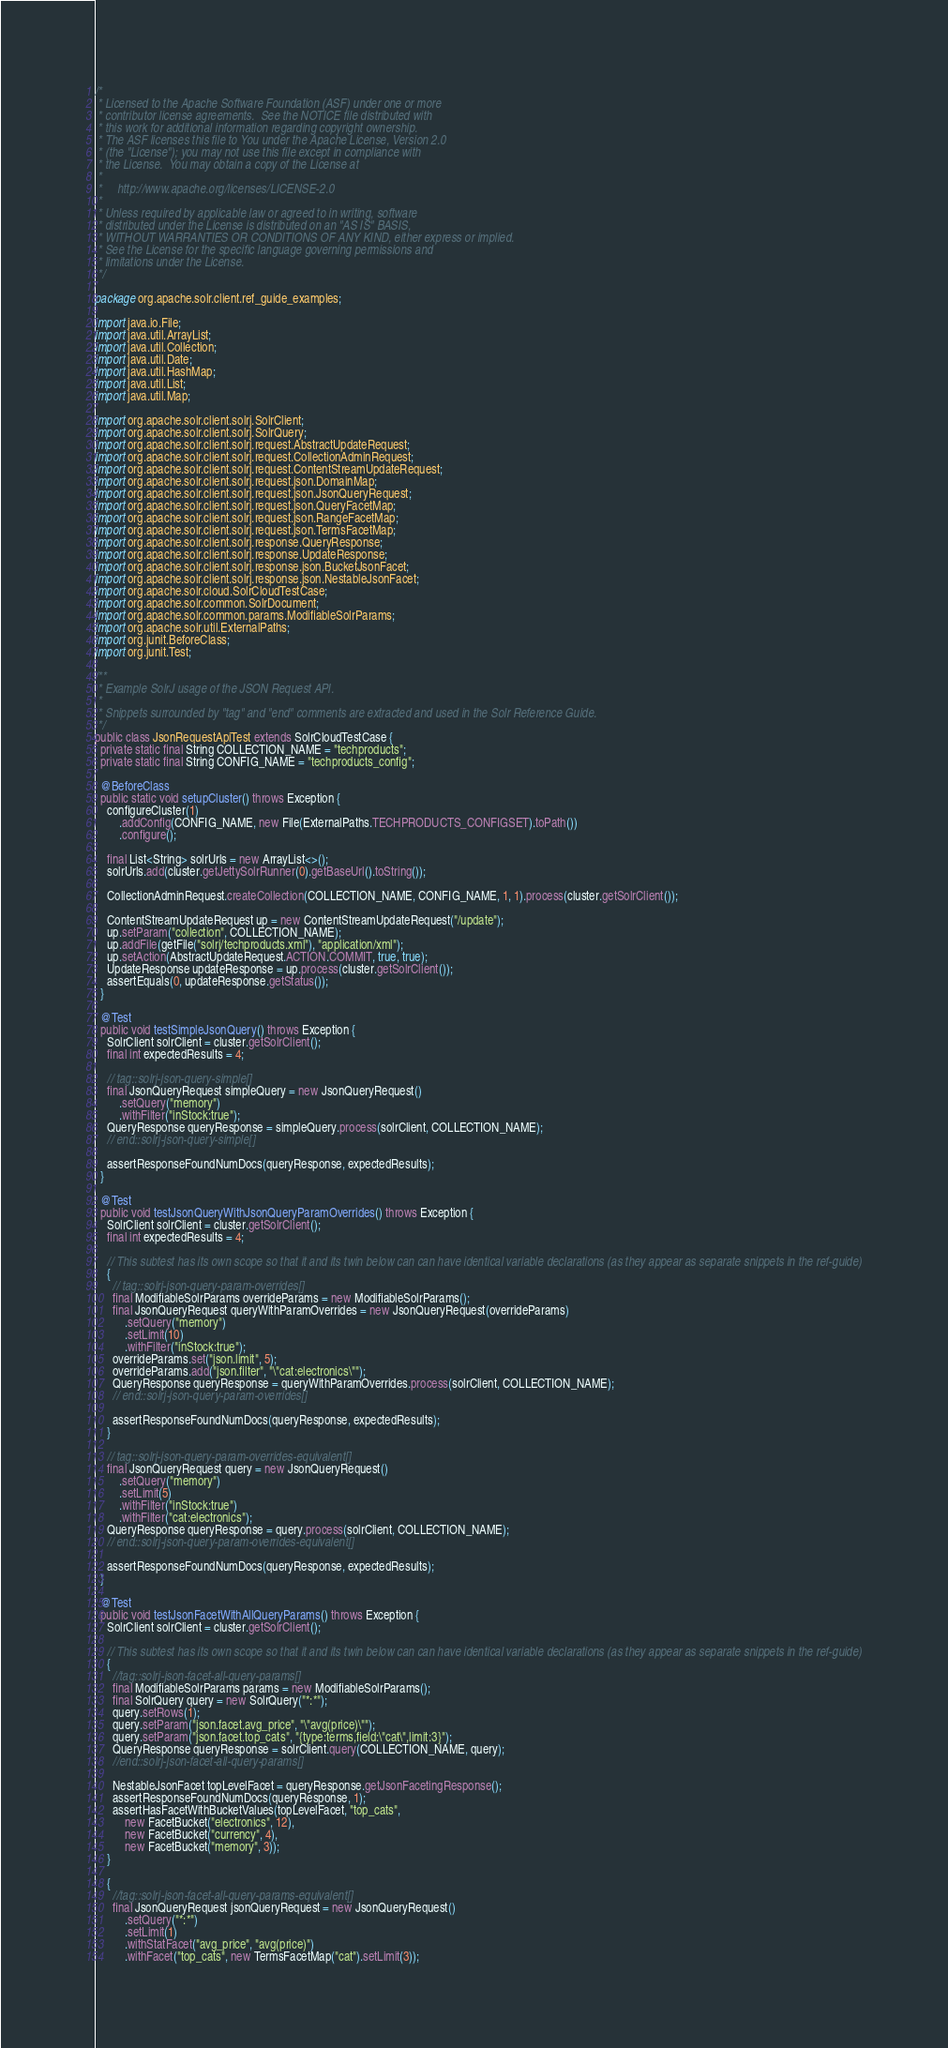<code> <loc_0><loc_0><loc_500><loc_500><_Java_>/*
 * Licensed to the Apache Software Foundation (ASF) under one or more
 * contributor license agreements.  See the NOTICE file distributed with
 * this work for additional information regarding copyright ownership.
 * The ASF licenses this file to You under the Apache License, Version 2.0
 * (the "License"); you may not use this file except in compliance with
 * the License.  You may obtain a copy of the License at
 *
 *     http://www.apache.org/licenses/LICENSE-2.0
 *
 * Unless required by applicable law or agreed to in writing, software
 * distributed under the License is distributed on an "AS IS" BASIS,
 * WITHOUT WARRANTIES OR CONDITIONS OF ANY KIND, either express or implied.
 * See the License for the specific language governing permissions and
 * limitations under the License.
 */

package org.apache.solr.client.ref_guide_examples;

import java.io.File;
import java.util.ArrayList;
import java.util.Collection;
import java.util.Date;
import java.util.HashMap;
import java.util.List;
import java.util.Map;

import org.apache.solr.client.solrj.SolrClient;
import org.apache.solr.client.solrj.SolrQuery;
import org.apache.solr.client.solrj.request.AbstractUpdateRequest;
import org.apache.solr.client.solrj.request.CollectionAdminRequest;
import org.apache.solr.client.solrj.request.ContentStreamUpdateRequest;
import org.apache.solr.client.solrj.request.json.DomainMap;
import org.apache.solr.client.solrj.request.json.JsonQueryRequest;
import org.apache.solr.client.solrj.request.json.QueryFacetMap;
import org.apache.solr.client.solrj.request.json.RangeFacetMap;
import org.apache.solr.client.solrj.request.json.TermsFacetMap;
import org.apache.solr.client.solrj.response.QueryResponse;
import org.apache.solr.client.solrj.response.UpdateResponse;
import org.apache.solr.client.solrj.response.json.BucketJsonFacet;
import org.apache.solr.client.solrj.response.json.NestableJsonFacet;
import org.apache.solr.cloud.SolrCloudTestCase;
import org.apache.solr.common.SolrDocument;
import org.apache.solr.common.params.ModifiableSolrParams;
import org.apache.solr.util.ExternalPaths;
import org.junit.BeforeClass;
import org.junit.Test;

/**
 * Example SolrJ usage of the JSON Request API.
 *
 * Snippets surrounded by "tag" and "end" comments are extracted and used in the Solr Reference Guide.
 */
public class JsonRequestApiTest extends SolrCloudTestCase {
  private static final String COLLECTION_NAME = "techproducts";
  private static final String CONFIG_NAME = "techproducts_config";

  @BeforeClass
  public static void setupCluster() throws Exception {
    configureCluster(1)
        .addConfig(CONFIG_NAME, new File(ExternalPaths.TECHPRODUCTS_CONFIGSET).toPath())
        .configure();

    final List<String> solrUrls = new ArrayList<>();
    solrUrls.add(cluster.getJettySolrRunner(0).getBaseUrl().toString());

    CollectionAdminRequest.createCollection(COLLECTION_NAME, CONFIG_NAME, 1, 1).process(cluster.getSolrClient());

    ContentStreamUpdateRequest up = new ContentStreamUpdateRequest("/update");
    up.setParam("collection", COLLECTION_NAME);
    up.addFile(getFile("solrj/techproducts.xml"), "application/xml");
    up.setAction(AbstractUpdateRequest.ACTION.COMMIT, true, true);
    UpdateResponse updateResponse = up.process(cluster.getSolrClient());
    assertEquals(0, updateResponse.getStatus());
  }

  @Test
  public void testSimpleJsonQuery() throws Exception {
    SolrClient solrClient = cluster.getSolrClient();
    final int expectedResults = 4;

    // tag::solrj-json-query-simple[]
    final JsonQueryRequest simpleQuery = new JsonQueryRequest()
        .setQuery("memory")
        .withFilter("inStock:true");
    QueryResponse queryResponse = simpleQuery.process(solrClient, COLLECTION_NAME);
    // end::solrj-json-query-simple[]

    assertResponseFoundNumDocs(queryResponse, expectedResults);
  }

  @Test
  public void testJsonQueryWithJsonQueryParamOverrides() throws Exception {
    SolrClient solrClient = cluster.getSolrClient();
    final int expectedResults = 4;

    // This subtest has its own scope so that it and its twin below can can have identical variable declarations (as they appear as separate snippets in the ref-guide)
    {
      // tag::solrj-json-query-param-overrides[]
      final ModifiableSolrParams overrideParams = new ModifiableSolrParams();
      final JsonQueryRequest queryWithParamOverrides = new JsonQueryRequest(overrideParams)
          .setQuery("memory")
          .setLimit(10)
          .withFilter("inStock:true");
      overrideParams.set("json.limit", 5);
      overrideParams.add("json.filter", "\"cat:electronics\"");
      QueryResponse queryResponse = queryWithParamOverrides.process(solrClient, COLLECTION_NAME);
      // end::solrj-json-query-param-overrides[]

      assertResponseFoundNumDocs(queryResponse, expectedResults);
    }

    // tag::solrj-json-query-param-overrides-equivalent[]
    final JsonQueryRequest query = new JsonQueryRequest()
        .setQuery("memory")
        .setLimit(5)
        .withFilter("inStock:true")
        .withFilter("cat:electronics");
    QueryResponse queryResponse = query.process(solrClient, COLLECTION_NAME);
    // end::solrj-json-query-param-overrides-equivalent[]

    assertResponseFoundNumDocs(queryResponse, expectedResults);
  }

  @Test
  public void testJsonFacetWithAllQueryParams() throws Exception {
    SolrClient solrClient = cluster.getSolrClient();

    // This subtest has its own scope so that it and its twin below can can have identical variable declarations (as they appear as separate snippets in the ref-guide)
    {
      //tag::solrj-json-facet-all-query-params[]
      final ModifiableSolrParams params = new ModifiableSolrParams();
      final SolrQuery query = new SolrQuery("*:*");
      query.setRows(1);
      query.setParam("json.facet.avg_price", "\"avg(price)\"");
      query.setParam("json.facet.top_cats", "{type:terms,field:\"cat\",limit:3}");
      QueryResponse queryResponse = solrClient.query(COLLECTION_NAME, query);
      //end::solrj-json-facet-all-query-params[]

      NestableJsonFacet topLevelFacet = queryResponse.getJsonFacetingResponse();
      assertResponseFoundNumDocs(queryResponse, 1);
      assertHasFacetWithBucketValues(topLevelFacet, "top_cats",
          new FacetBucket("electronics", 12),
          new FacetBucket("currency", 4),
          new FacetBucket("memory", 3));
    }

    {
      //tag::solrj-json-facet-all-query-params-equivalent[]
      final JsonQueryRequest jsonQueryRequest = new JsonQueryRequest()
          .setQuery("*:*")
          .setLimit(1)
          .withStatFacet("avg_price", "avg(price)")
          .withFacet("top_cats", new TermsFacetMap("cat").setLimit(3));</code> 